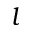<formula> <loc_0><loc_0><loc_500><loc_500>l</formula> 